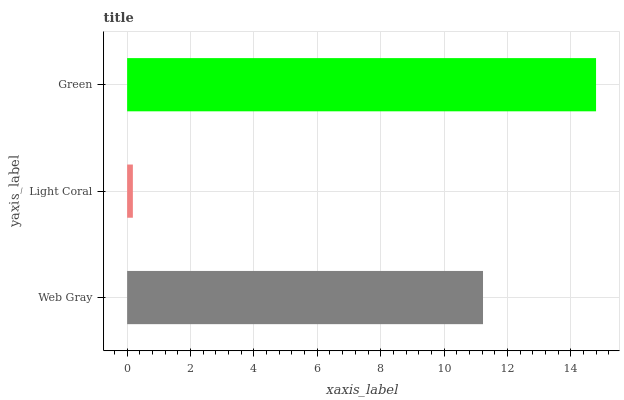Is Light Coral the minimum?
Answer yes or no. Yes. Is Green the maximum?
Answer yes or no. Yes. Is Green the minimum?
Answer yes or no. No. Is Light Coral the maximum?
Answer yes or no. No. Is Green greater than Light Coral?
Answer yes or no. Yes. Is Light Coral less than Green?
Answer yes or no. Yes. Is Light Coral greater than Green?
Answer yes or no. No. Is Green less than Light Coral?
Answer yes or no. No. Is Web Gray the high median?
Answer yes or no. Yes. Is Web Gray the low median?
Answer yes or no. Yes. Is Green the high median?
Answer yes or no. No. Is Green the low median?
Answer yes or no. No. 